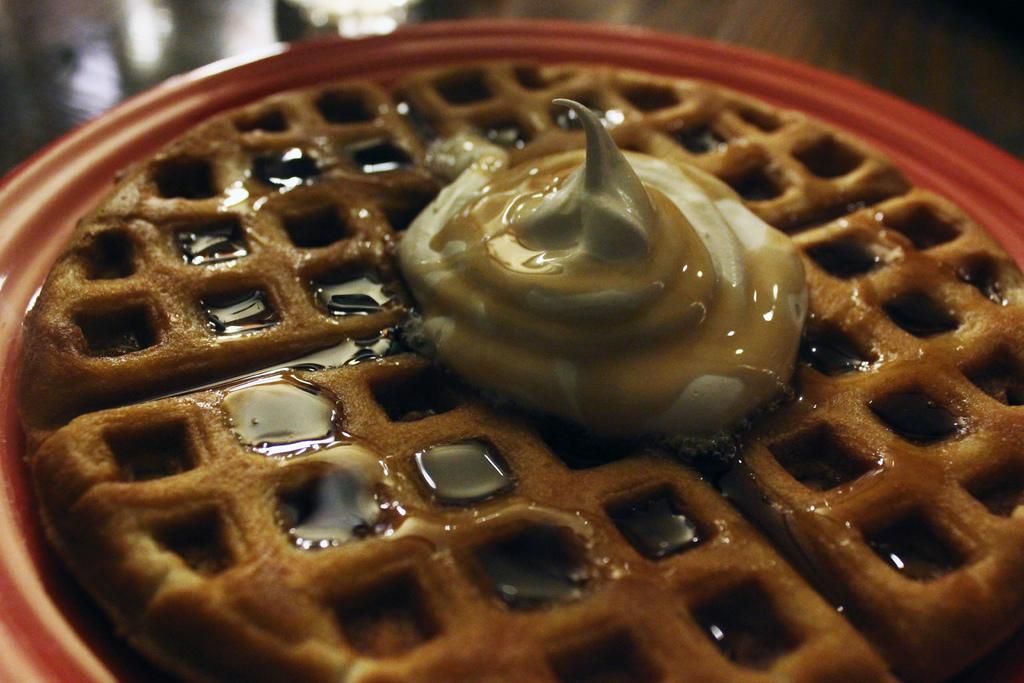What is present on the plate in the image? There is food in a plate in the image. What type of sponge can be seen soaking in the food on the plate? There is no sponge present in the image; it is a plate of food. How many pears are visible on the plate? There are no pears visible on the plate; it is a plate of food. 